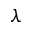Convert formula to latex. <formula><loc_0><loc_0><loc_500><loc_500>\lambda</formula> 